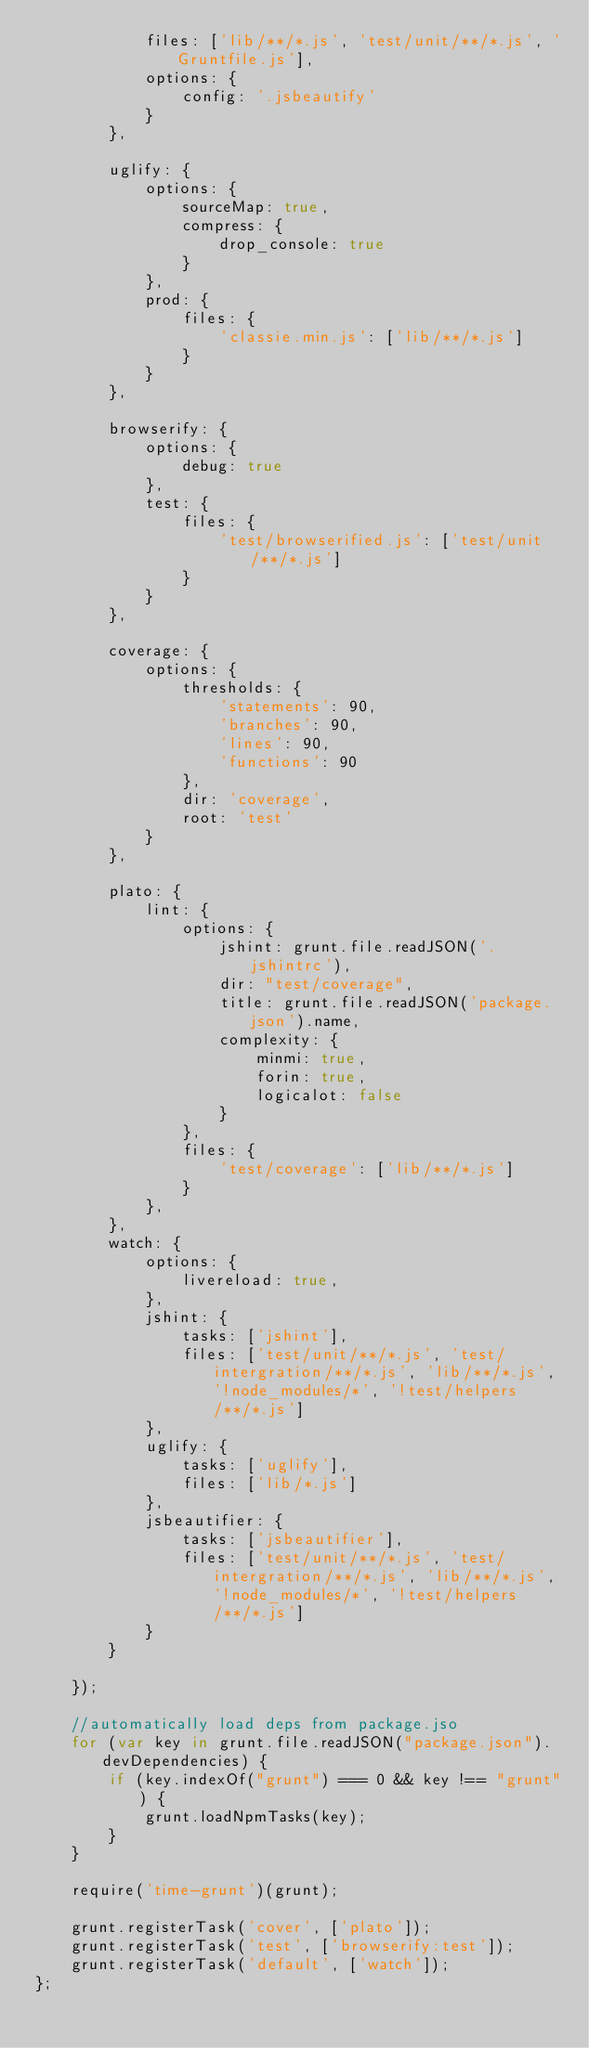<code> <loc_0><loc_0><loc_500><loc_500><_JavaScript_>            files: ['lib/**/*.js', 'test/unit/**/*.js', 'Gruntfile.js'],
            options: {
                config: '.jsbeautify'
            }
        },

        uglify: {
            options: {
                sourceMap: true,
                compress: {
                    drop_console: true
                }
            },
            prod: {
                files: {
                    'classie.min.js': ['lib/**/*.js']
                }
            }
        },

        browserify: {
            options: {
                debug: true
            },
            test: {
                files: {
                    'test/browserified.js': ['test/unit/**/*.js']
                }
            }
        },

        coverage: {
            options: {
                thresholds: {
                    'statements': 90,
                    'branches': 90,
                    'lines': 90,
                    'functions': 90
                },
                dir: 'coverage',
                root: 'test'
            }
        },

        plato: {
            lint: {
                options: {
                    jshint: grunt.file.readJSON('.jshintrc'),
                    dir: "test/coverage",
                    title: grunt.file.readJSON('package.json').name,
                    complexity: {
                        minmi: true,
                        forin: true,
                        logicalot: false
                    }
                },
                files: {
                    'test/coverage': ['lib/**/*.js']
                }
            },
        },
        watch: {
            options: {
                livereload: true,
            },
            jshint: {
                tasks: ['jshint'],
                files: ['test/unit/**/*.js', 'test/intergration/**/*.js', 'lib/**/*.js', '!node_modules/*', '!test/helpers/**/*.js']
            },
            uglify: {
                tasks: ['uglify'],
                files: ['lib/*.js']
            },
            jsbeautifier: {
                tasks: ['jsbeautifier'],
                files: ['test/unit/**/*.js', 'test/intergration/**/*.js', 'lib/**/*.js', '!node_modules/*', '!test/helpers/**/*.js']
            }
        }

    });

    //automatically load deps from package.jso
    for (var key in grunt.file.readJSON("package.json").devDependencies) {
        if (key.indexOf("grunt") === 0 && key !== "grunt") {
            grunt.loadNpmTasks(key);
        }
    }

    require('time-grunt')(grunt);

    grunt.registerTask('cover', ['plato']);
    grunt.registerTask('test', ['browserify:test']);
    grunt.registerTask('default', ['watch']);
};
</code> 